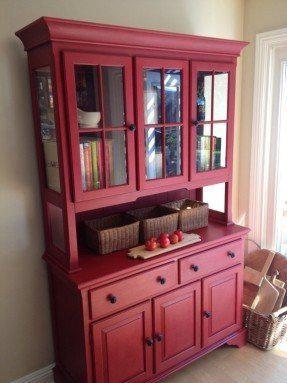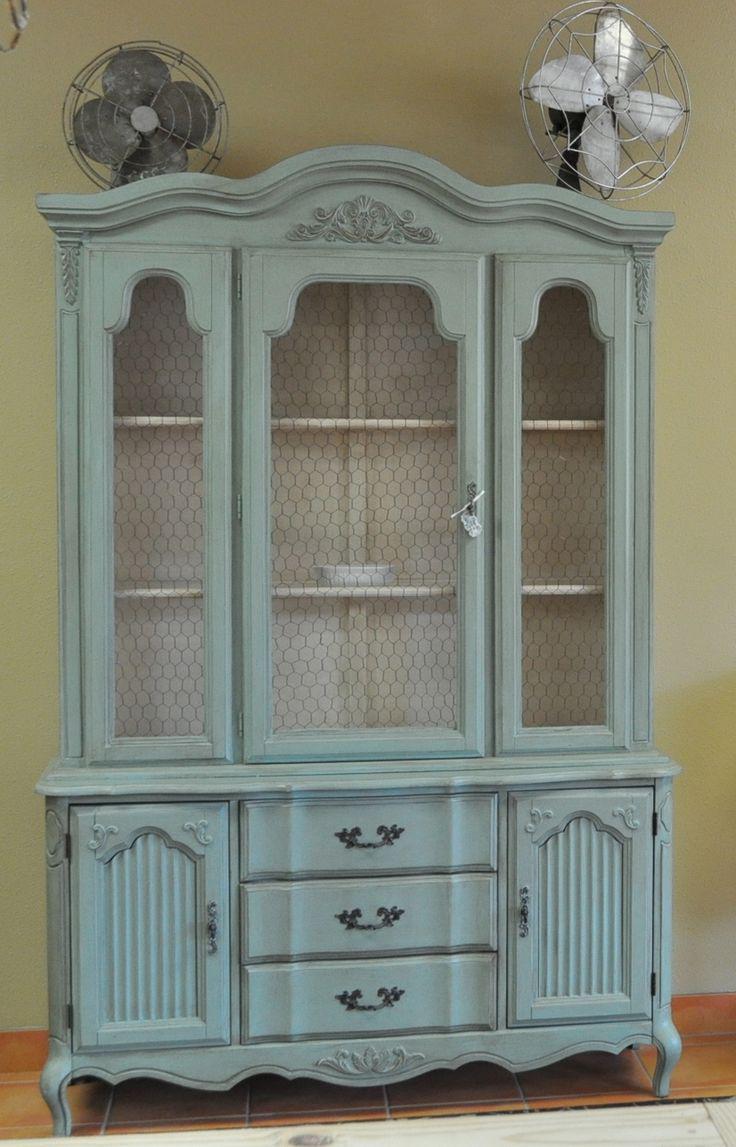The first image is the image on the left, the second image is the image on the right. Considering the images on both sides, is "All cabinets shown are rich brown wood tones." valid? Answer yes or no. No. 